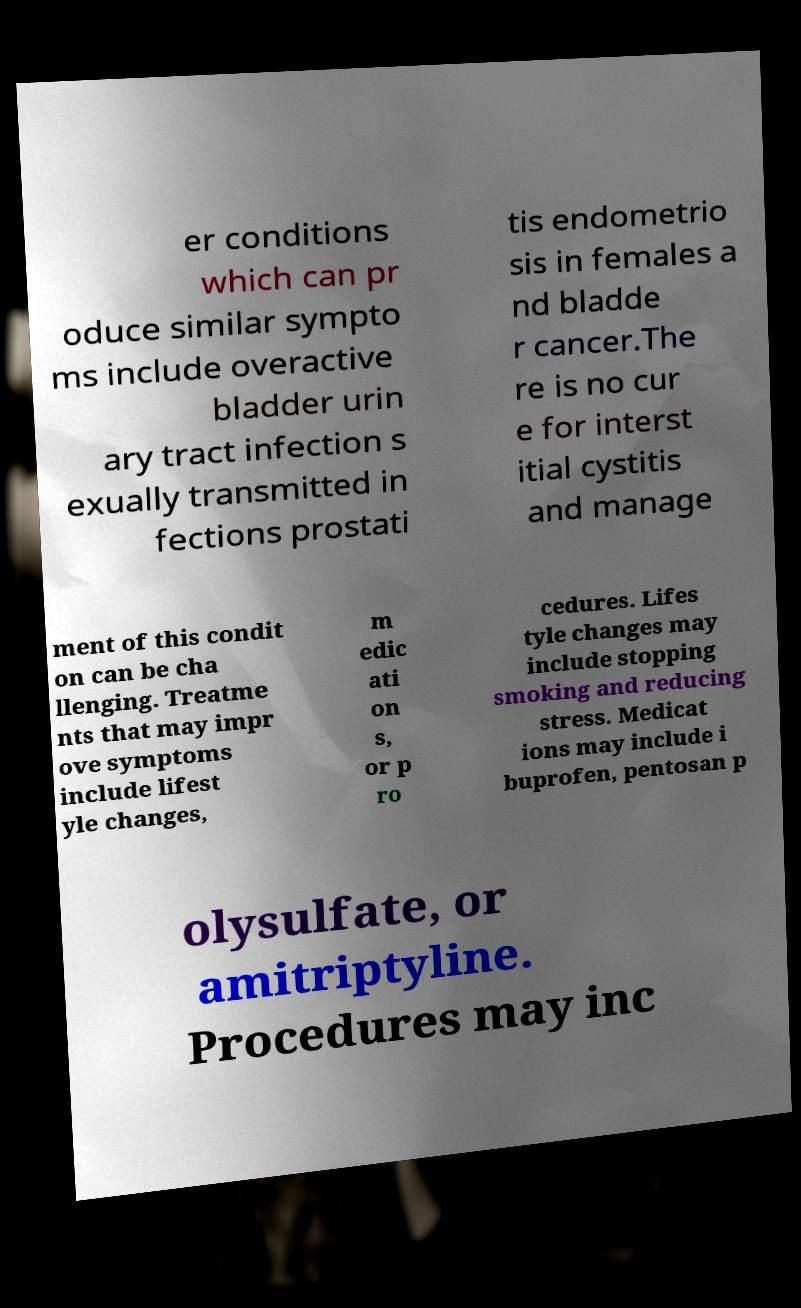I need the written content from this picture converted into text. Can you do that? er conditions which can pr oduce similar sympto ms include overactive bladder urin ary tract infection s exually transmitted in fections prostati tis endometrio sis in females a nd bladde r cancer.The re is no cur e for interst itial cystitis and manage ment of this condit on can be cha llenging. Treatme nts that may impr ove symptoms include lifest yle changes, m edic ati on s, or p ro cedures. Lifes tyle changes may include stopping smoking and reducing stress. Medicat ions may include i buprofen, pentosan p olysulfate, or amitriptyline. Procedures may inc 